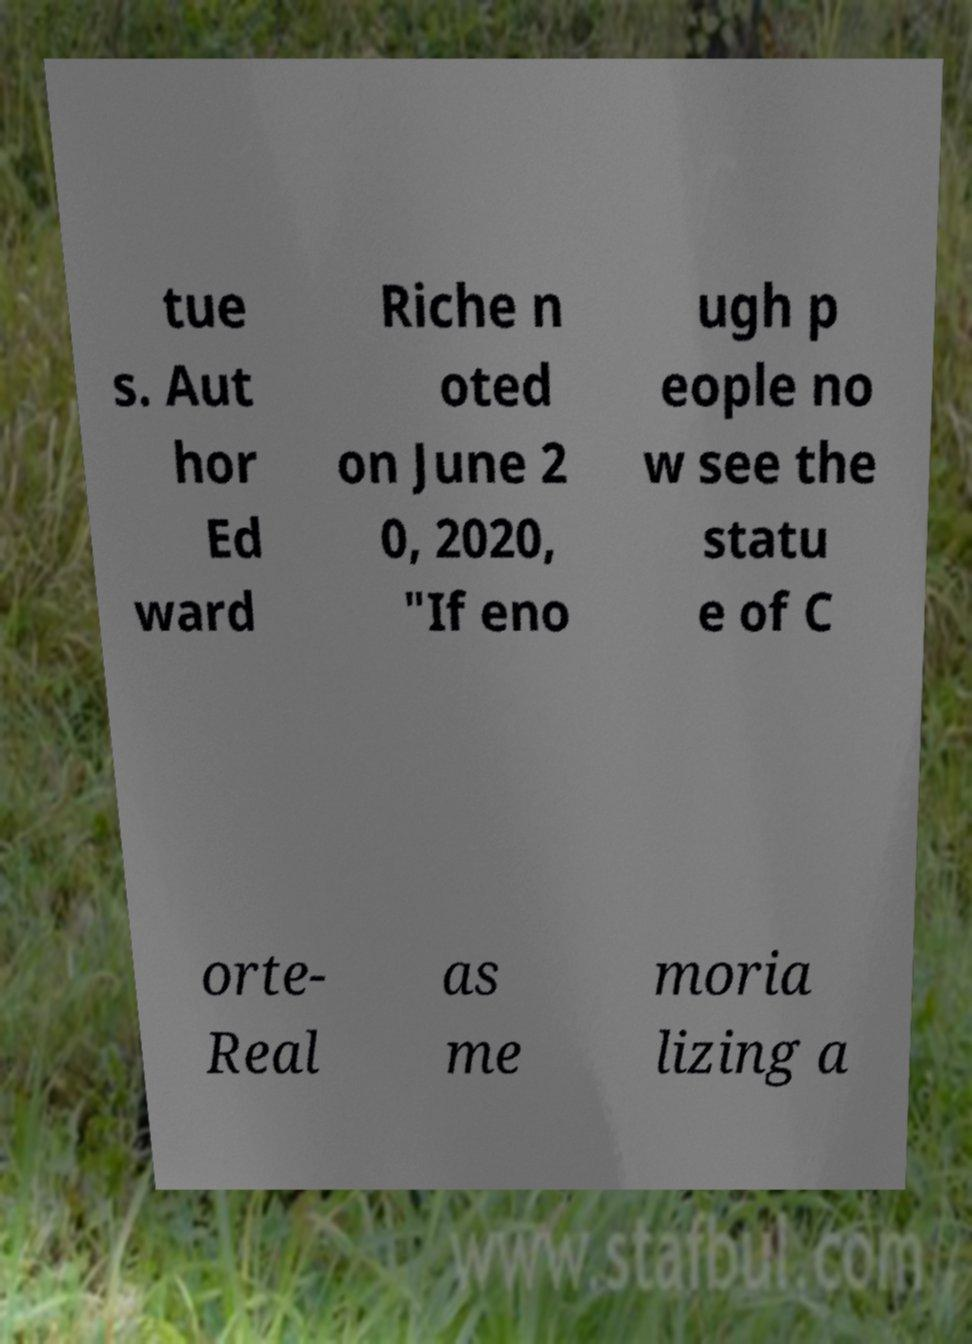Please identify and transcribe the text found in this image. tue s. Aut hor Ed ward Riche n oted on June 2 0, 2020, "If eno ugh p eople no w see the statu e of C orte- Real as me moria lizing a 